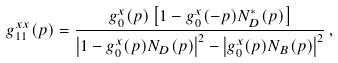Convert formula to latex. <formula><loc_0><loc_0><loc_500><loc_500>g ^ { x x } _ { 1 1 } ( { p } ) = \frac { g ^ { x } _ { 0 } ( { p } ) \left [ 1 - g ^ { x } _ { 0 } ( - { p } ) N _ { D } ^ { * } ( { p } ) \right ] } { \left | 1 - g ^ { x } _ { 0 } ( { p } ) N _ { D } ( { p } ) \right | ^ { 2 } - \left | g ^ { x } _ { 0 } ( { p } ) N _ { B } ( { p } ) \right | ^ { 2 } } \, ,</formula> 